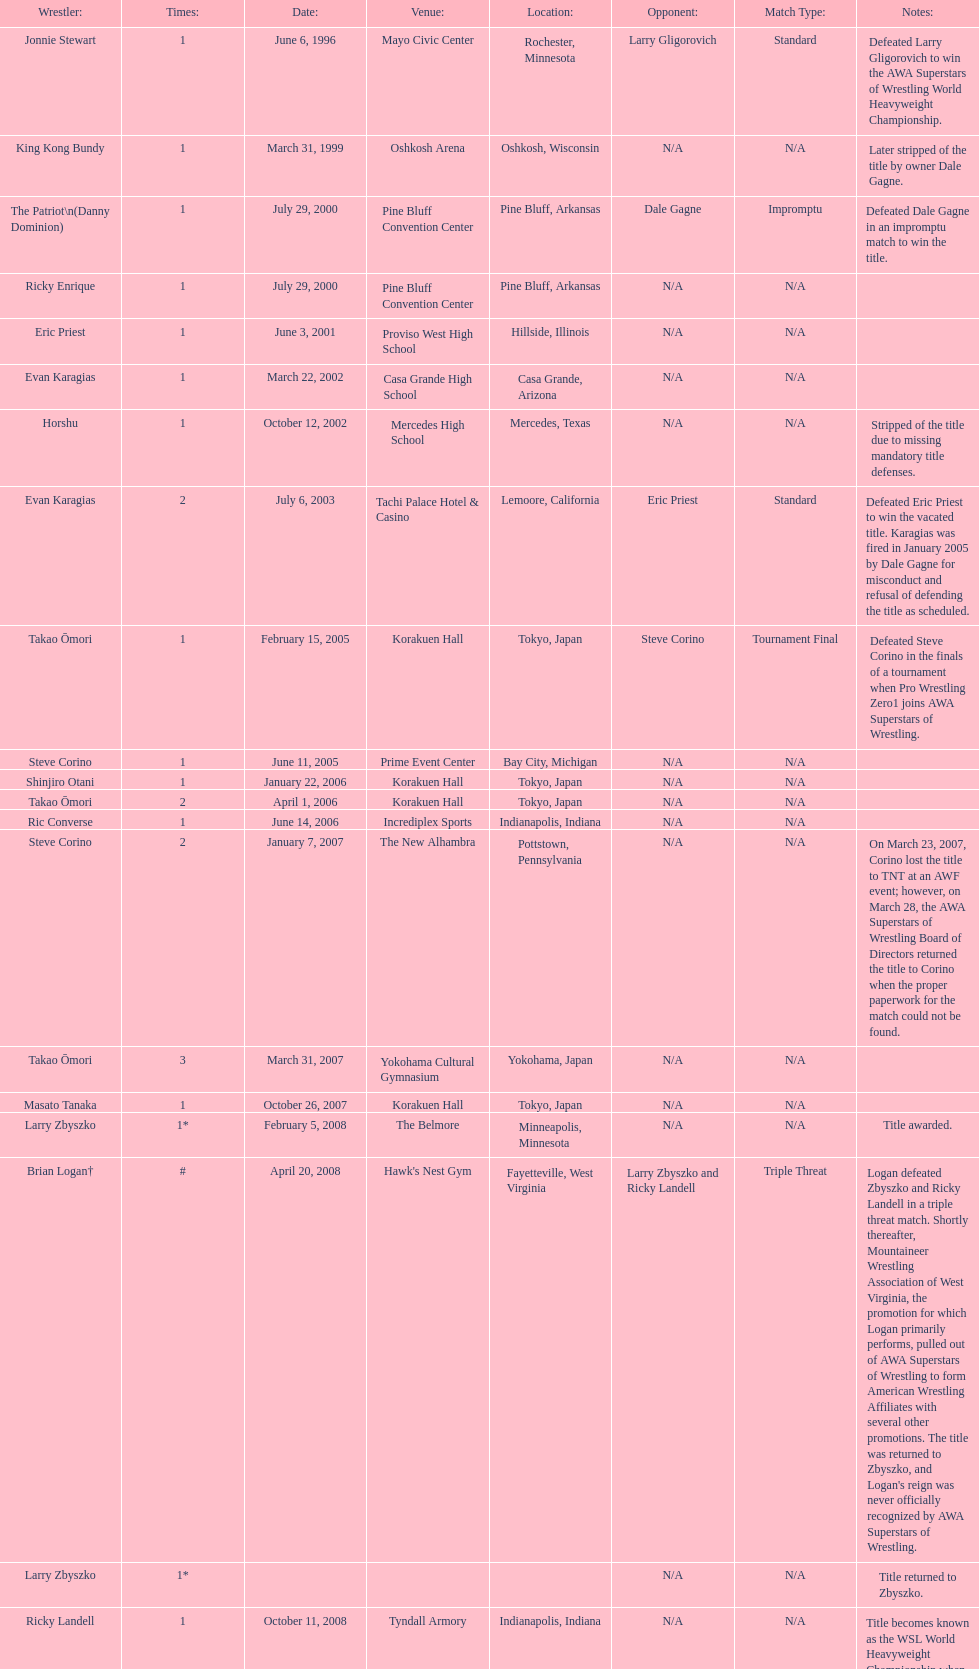The patriot (danny dominion) won the title from what previous holder through an impromptu match? Dale Gagne. 